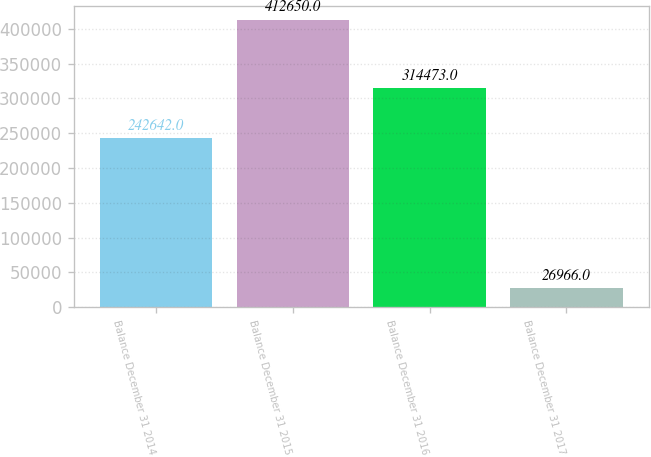Convert chart to OTSL. <chart><loc_0><loc_0><loc_500><loc_500><bar_chart><fcel>Balance December 31 2014<fcel>Balance December 31 2015<fcel>Balance December 31 2016<fcel>Balance December 31 2017<nl><fcel>242642<fcel>412650<fcel>314473<fcel>26966<nl></chart> 